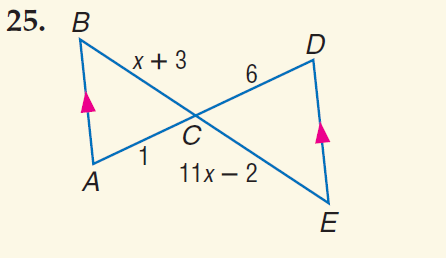Answer the mathemtical geometry problem and directly provide the correct option letter.
Question: Find x.
Choices: A: 3 B: 4 C: 6 D: 7 B 